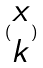Convert formula to latex. <formula><loc_0><loc_0><loc_500><loc_500>( \begin{matrix} x \\ k \end{matrix} )</formula> 